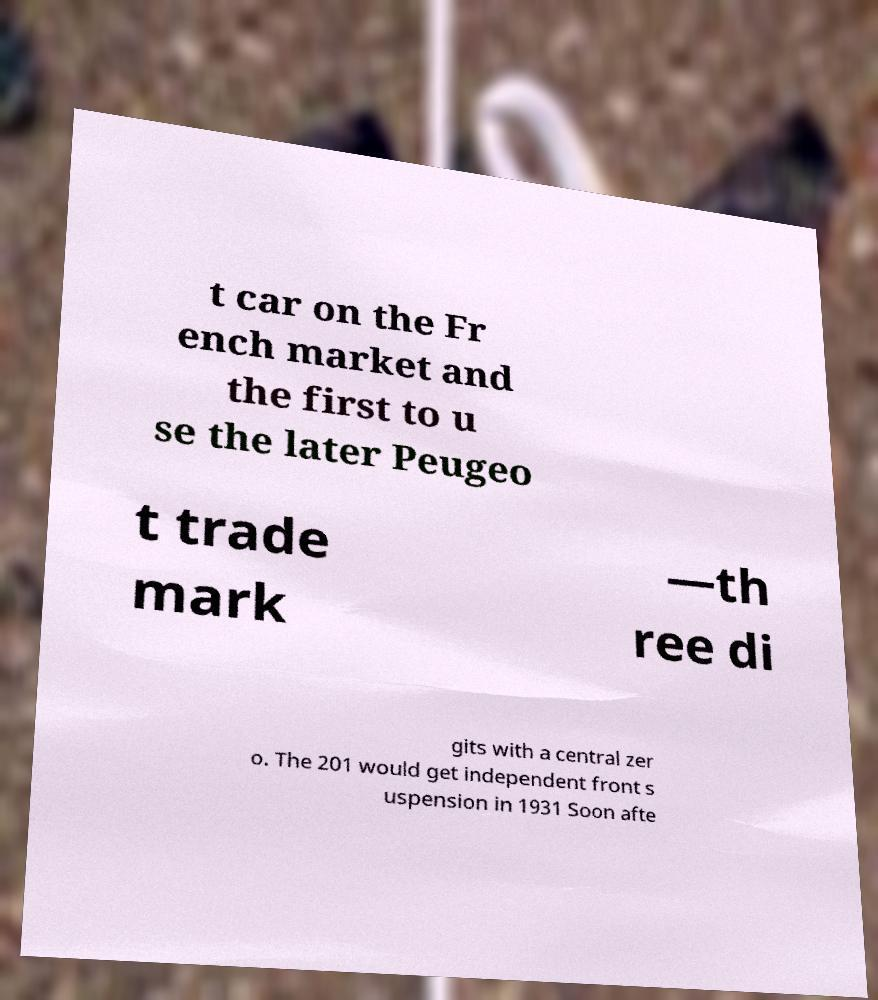Can you accurately transcribe the text from the provided image for me? t car on the Fr ench market and the first to u se the later Peugeo t trade mark —th ree di gits with a central zer o. The 201 would get independent front s uspension in 1931 Soon afte 